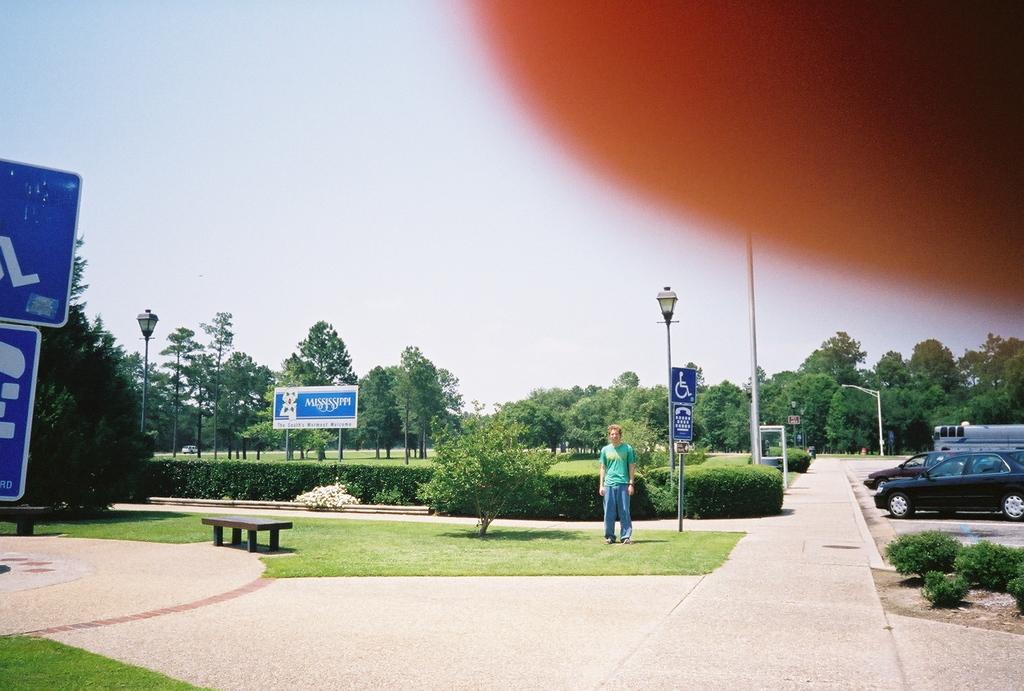In one or two sentences, can you explain what this image depicts? In this picture I can see a man standing and I can see few trees and a board with some text and I can see few sign boards and pole lights and I can see cars parked and I can see few plants and a bench and I can see cloudy sky. 